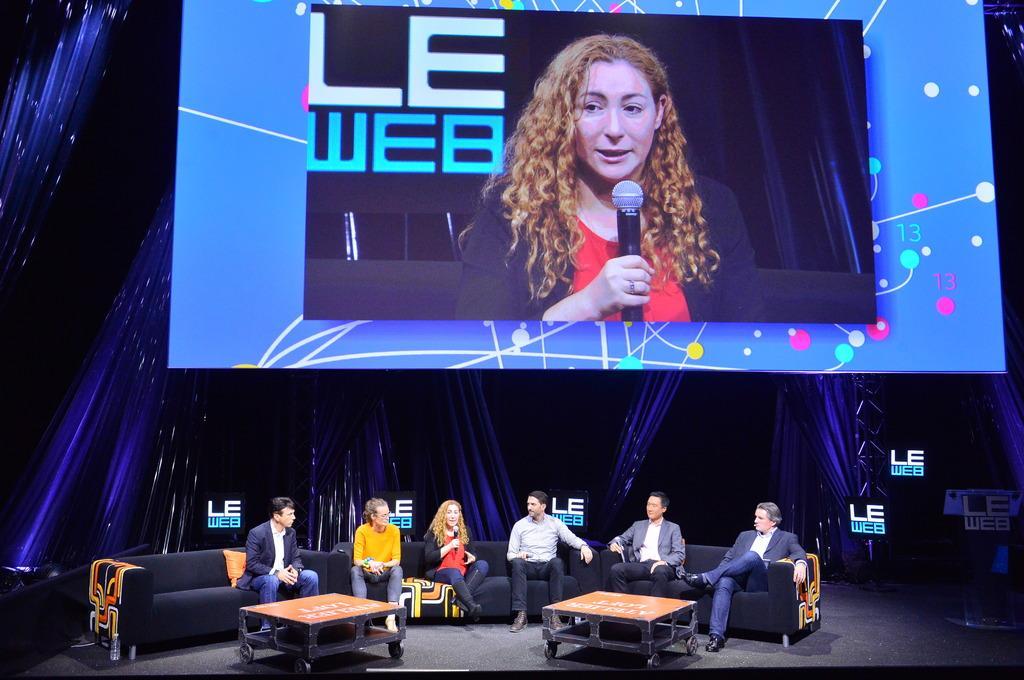Can you describe this image briefly? In this image I can see few people are sitting on the couches which are placed on the stage. In front of these people there are two tables. One woman is holding a mike in the hand and speaking. In the background, I can see the curtains. At the top of the image there is a screen on which I can see the woman who is speaking by holding a mike in the hand. 